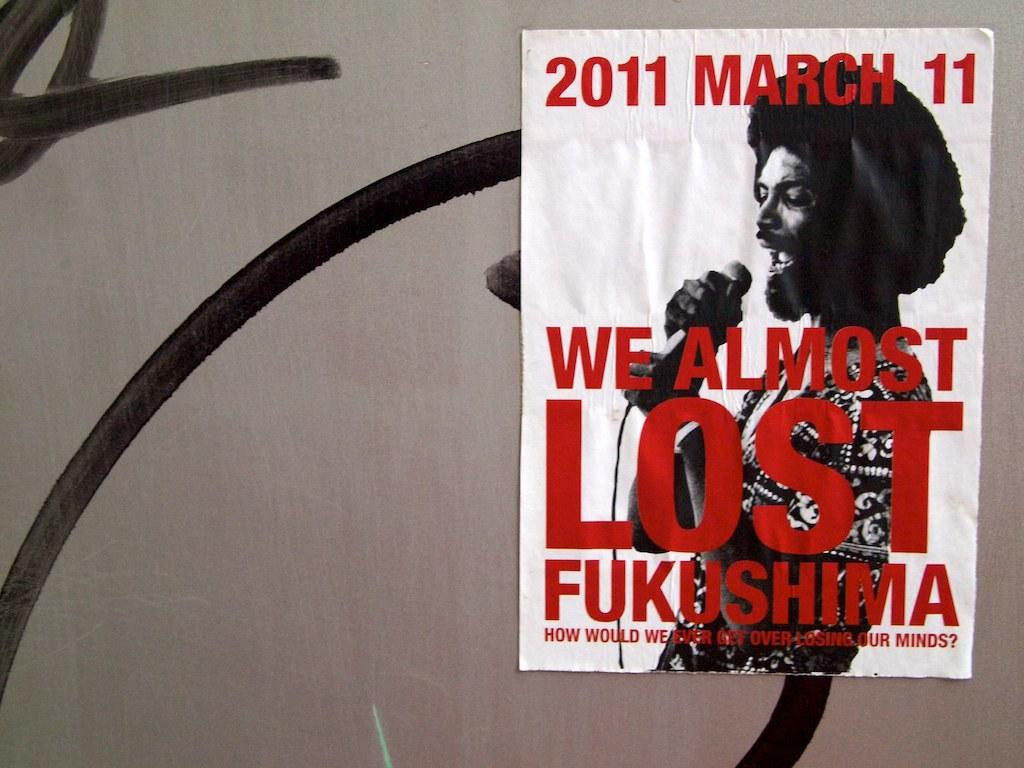Provide a one-sentence caption for the provided image. A poster advertises a concert that took place on March 11th, 2011. 